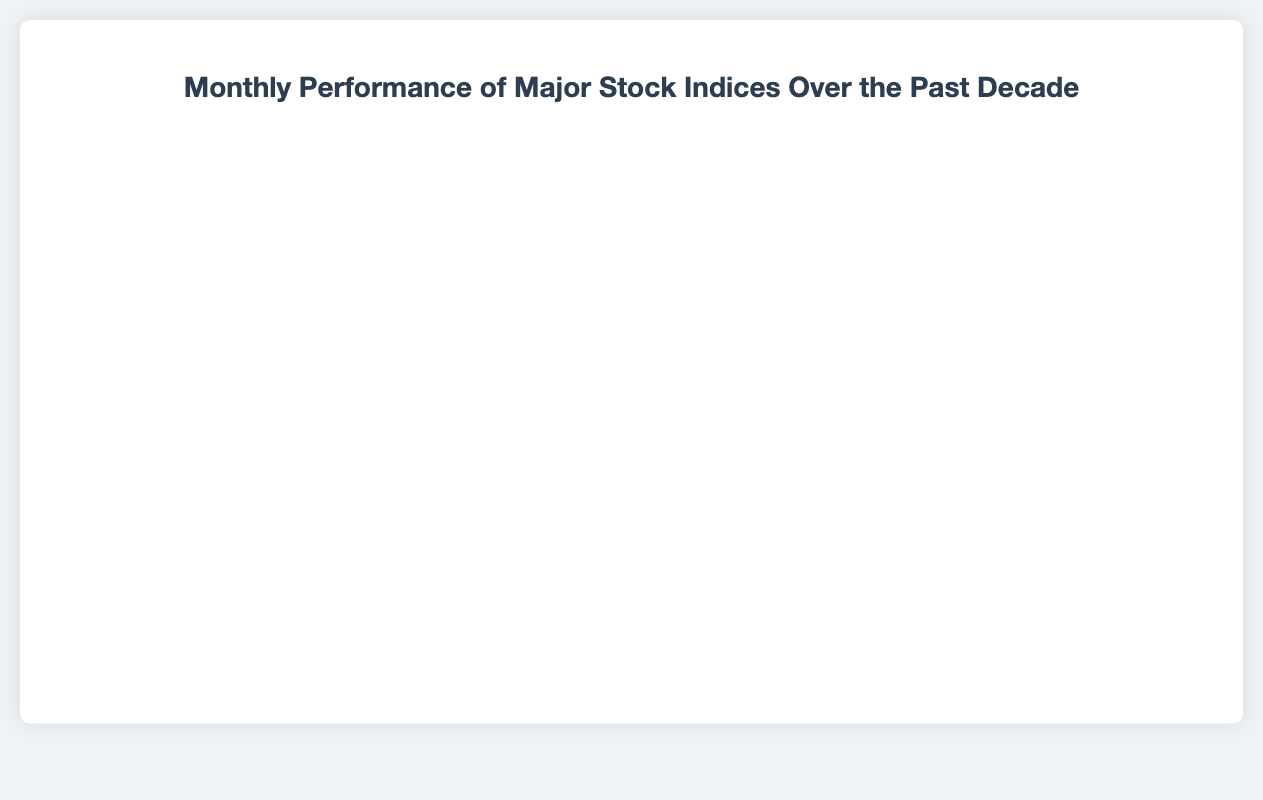What was the peak value of the S&P 500 over the past decade? The S&P 500 reached its highest value towards the end of the decade. By visually tracing the red line representing the S&P 500, the peak value appears to be around 4500 in 2022.
Answer: 4530.41 Between 2017 and 2020, which index showed the most consistent upward trend? By comparing the slopes of the lines representing each index between 2017 and 2020, the Nasdaq (represented by the green line) showed the most consistent upward trend without significant dips.
Answer: Nasdaq How did the FTSE 100 index perform in the first half of 2020 and what might explain the trend? The purple line for the FTSE 100 dips significantly in March 2020 and slightly recovers in April and May 2020. This downward trend corresponds with the global economic downturn due to the COVID-19 pandemic.
Answer: Declined significantly, likely due to the pandemic What was the relative performance of the Dow Jones and Nasdaq indices in May 2023? In May 2023, the blue line for the Dow Jones is around 32700, while the green line for the Nasdaq is around 13000. By comparison, Nasdaq showed a higher relative performance considering the overall trend and values.
Answer: Nasdaq performed relatively better What noticeable trend occurred in the S&P 500 index from January 2020 to May 2020? The red line for the S&P 500 shows a sharp drop from January to March 2020, after which it gradually recovers by May 2020. This trend can be attributed to the initial impact and subsequent recovery efforts during the COVID-19 pandemic.
Answer: Sharp drop followed by gradual recovery Which index had the highest value at any point in time over the past decade? By observing the lines representing each index over the entire period, the Dow Jones (blue line) had the highest value, peaking above 35000 in early 2022.
Answer: Dow Jones Calculate the average value of the FTSE 100 index during the first quarter of 2013. The first quarter values for FTSE 100 in 2013 are 6276.78, 6360.81, and 6411.74. Summing these values gives 19049.33, and the average is 19049.33/3 = 6350 approximately.
Answer: 6350 From January 2019 to December 2019, which index exhibited the highest total increase in value? Comparing the values from January 2019 to December 2019, Nasdaq shows a significant increase from about 7281 to 8049, indicating the highest total increase.
Answer: Nasdaq During which month and year did the S&P 500 first cross 3000? By following the red line for S&P 500, it first crosses the 3000 mark in January 2020.
Answer: January 2020 Compare the lowest values of FTSE 100 and Nasdaq through the entire decade. Which one had a lower minimum value and when? The purple line representing FTSE 100 hits its lowest around 5672 in March 2020, while the green line for Nasdaq hits its lowest around 3142 in early 2013. FTSE 100 had a lower minimum value.
Answer: FTSE 100 in March 2020 